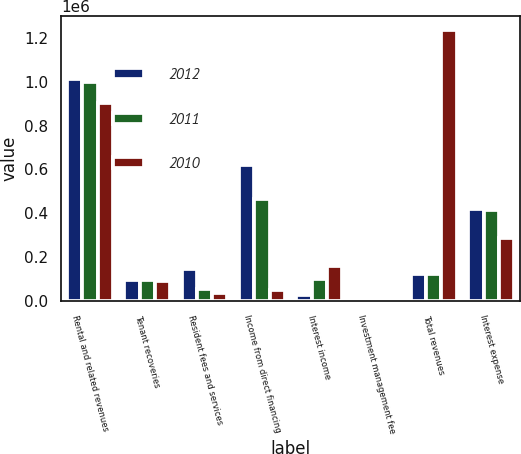Convert chart. <chart><loc_0><loc_0><loc_500><loc_500><stacked_bar_chart><ecel><fcel>Rental and related revenues<fcel>Tenant recoveries<fcel>Resident fees and services<fcel>Income from direct financing<fcel>Interest income<fcel>Investment management fee<fcel>Total revenues<fcel>Interest expense<nl><fcel>2012<fcel>1.01382e+06<fcel>94658<fcel>143745<fcel>622073<fcel>24536<fcel>1895<fcel>121804<fcel>417130<nl><fcel>2011<fcel>1.00258e+06<fcel>92258<fcel>50619<fcel>464704<fcel>99864<fcel>2073<fcel>121804<fcel>416396<nl><fcel>2010<fcel>904332<fcel>89011<fcel>32596<fcel>49438<fcel>160163<fcel>4666<fcel>1.24021e+06<fcel>285508<nl></chart> 